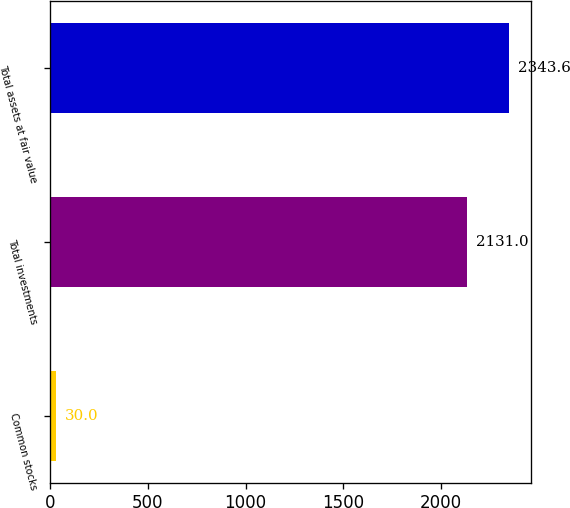Convert chart. <chart><loc_0><loc_0><loc_500><loc_500><bar_chart><fcel>Common stocks<fcel>Total investments<fcel>Total assets at fair value<nl><fcel>30<fcel>2131<fcel>2343.6<nl></chart> 